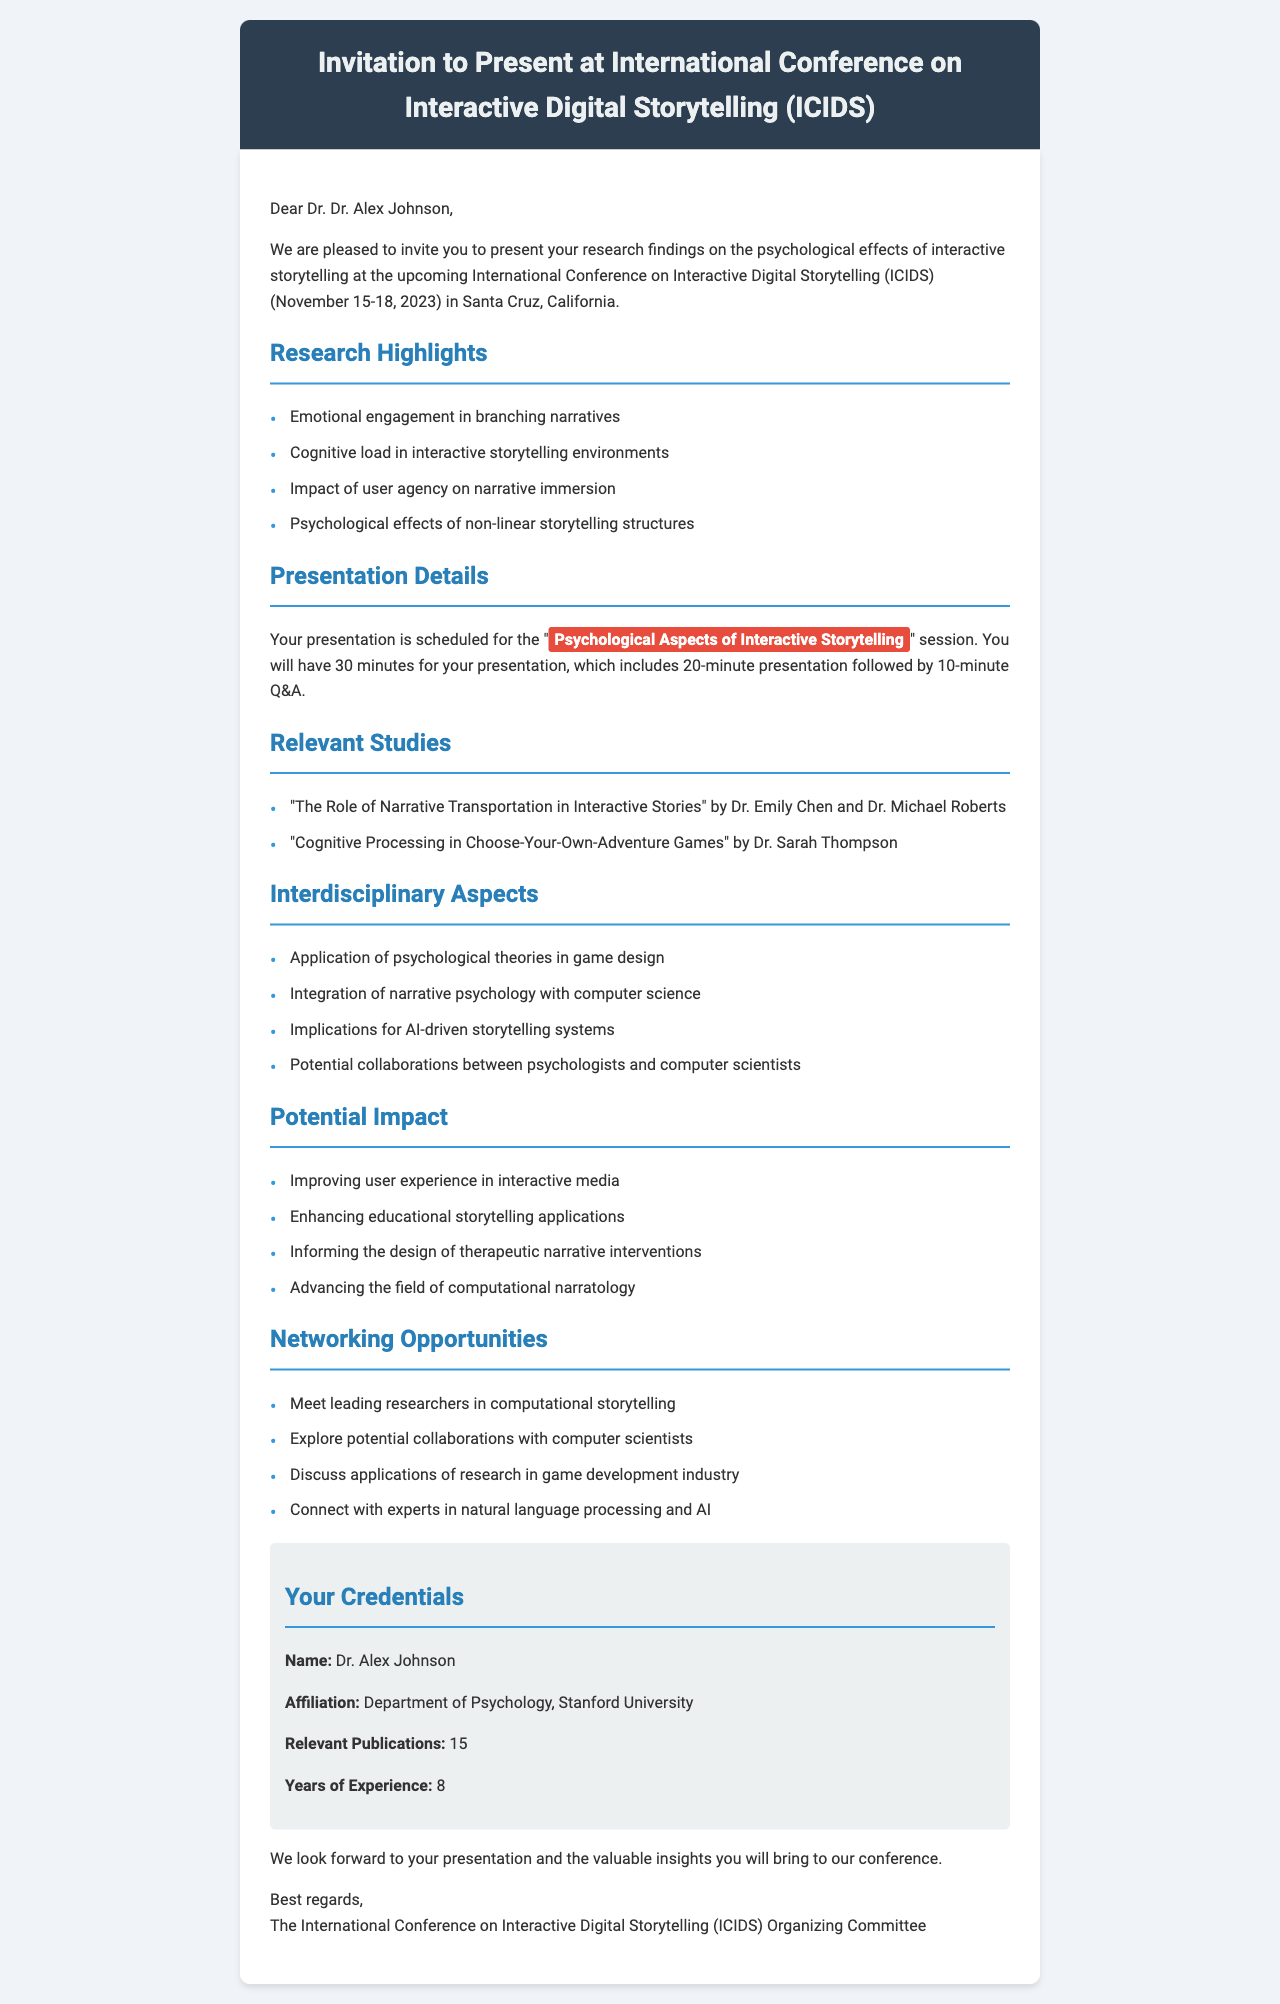What is the name of the conference? The name of the conference is mentioned in the document as "International Conference on Interactive Digital Storytelling (ICIDS)."
Answer: International Conference on Interactive Digital Storytelling (ICIDS) What are the dates of the conference? The document specifies the dates of the conference as November 15-18, 2023.
Answer: November 15-18, 2023 How long is the presentation scheduled for? The duration of the presentation is detailed in the document as 30 minutes.
Answer: 30 minutes Who are the authors of one of the relevant studies? The document lists Dr. Emily Chen and Dr. Michael Roberts as the authors of one relevant study.
Answer: Dr. Emily Chen and Dr. Michael Roberts What is one of the psychological aspects being discussed? The document highlights "Emotional engagement in branching narratives" as a psychological aspect.
Answer: Emotional engagement in branching narratives What session is the presentation scheduled for? The session for the presentation is stated in the document as "Psychological Aspects of Interactive Storytelling."
Answer: Psychological Aspects of Interactive Storytelling What institution is organizing the conference? The organizer of the conference is mentioned in the document as the University of California, Santa Cruz.
Answer: University of California, Santa Cruz What is a potential impact of the research? The document states that one potential impact is "Improving user experience in interactive media."
Answer: Improving user experience in interactive media What are the networking opportunities mentioned? The document lists several networking opportunities, one of which is "Meet leading researchers in computational storytelling."
Answer: Meet leading researchers in computational storytelling 